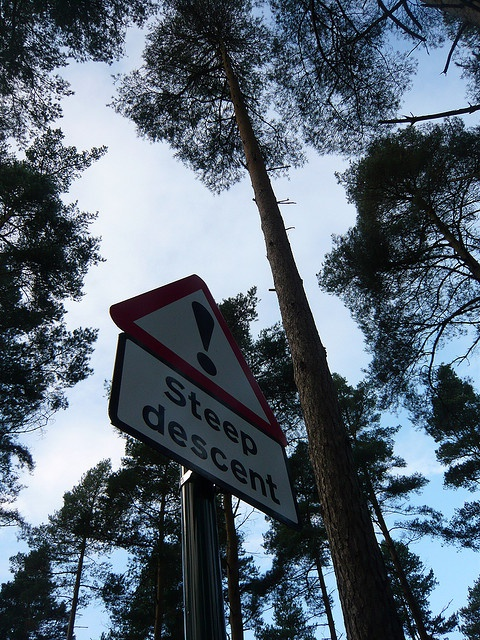Describe the objects in this image and their specific colors. I can see various objects in this image with different colors. 